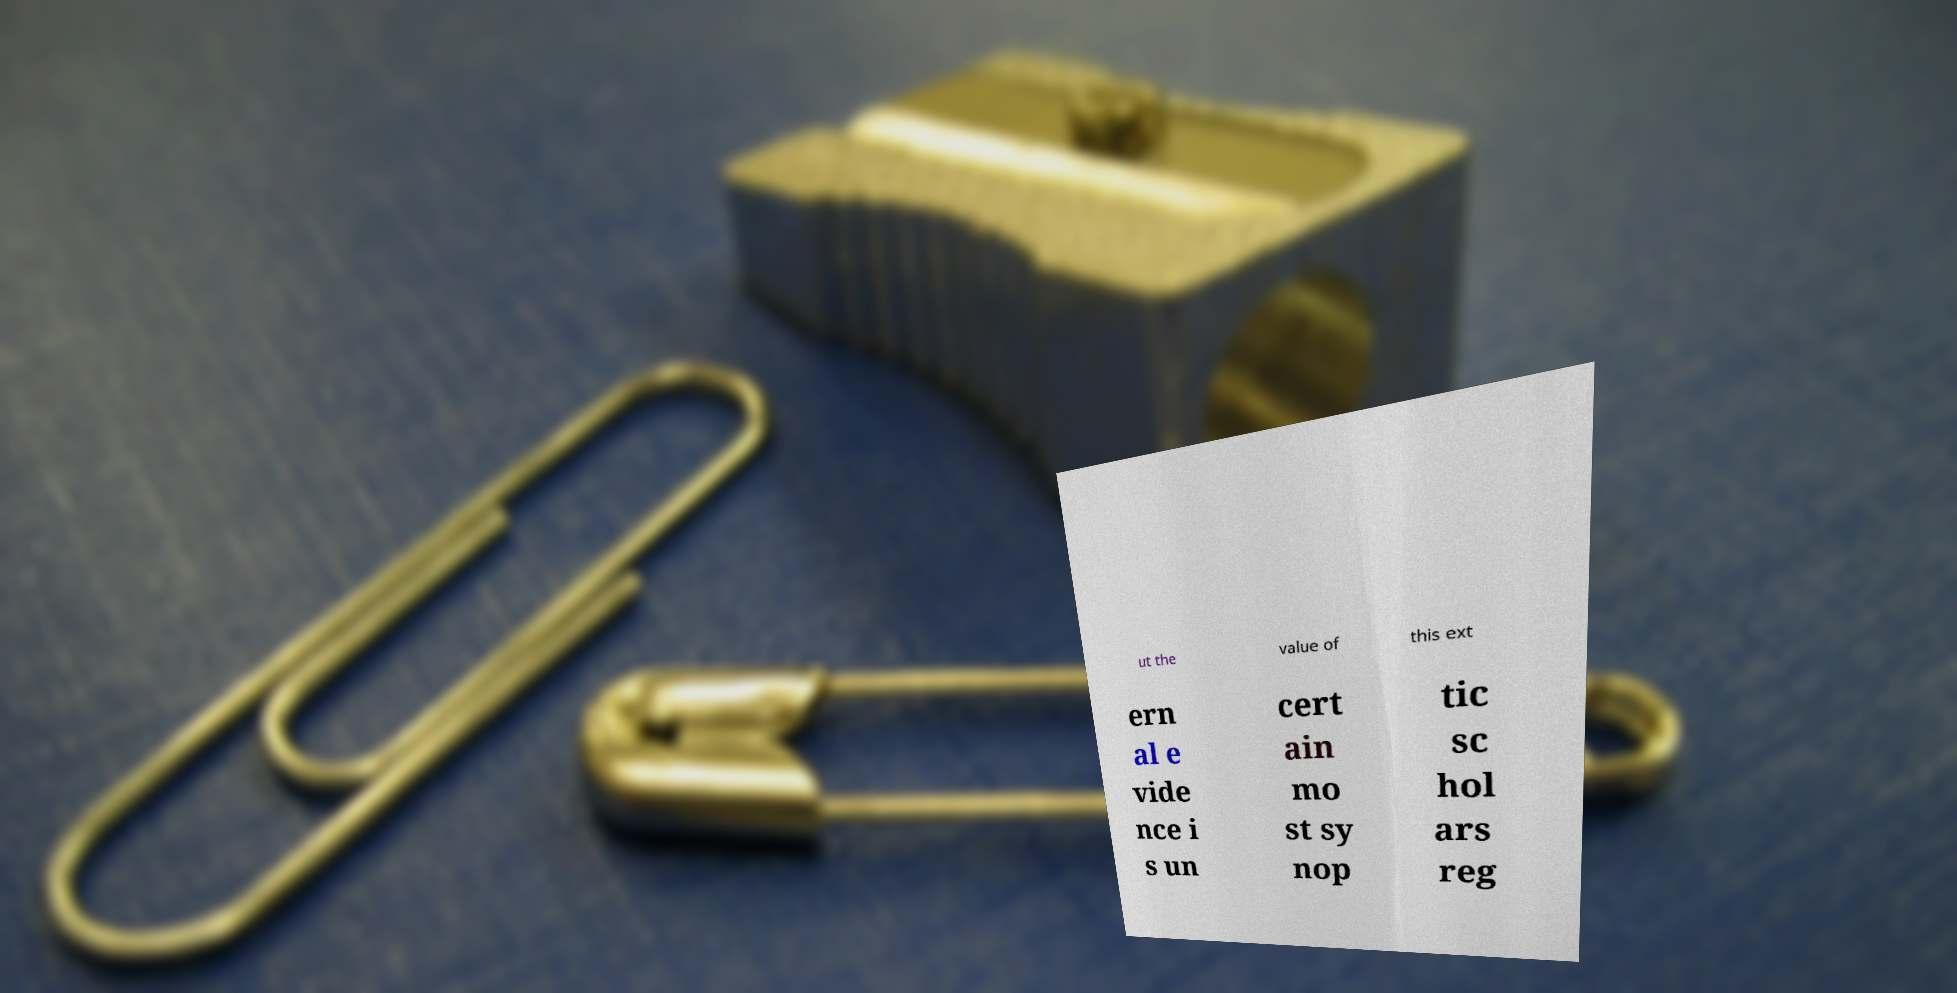Can you read and provide the text displayed in the image?This photo seems to have some interesting text. Can you extract and type it out for me? ut the value of this ext ern al e vide nce i s un cert ain mo st sy nop tic sc hol ars reg 